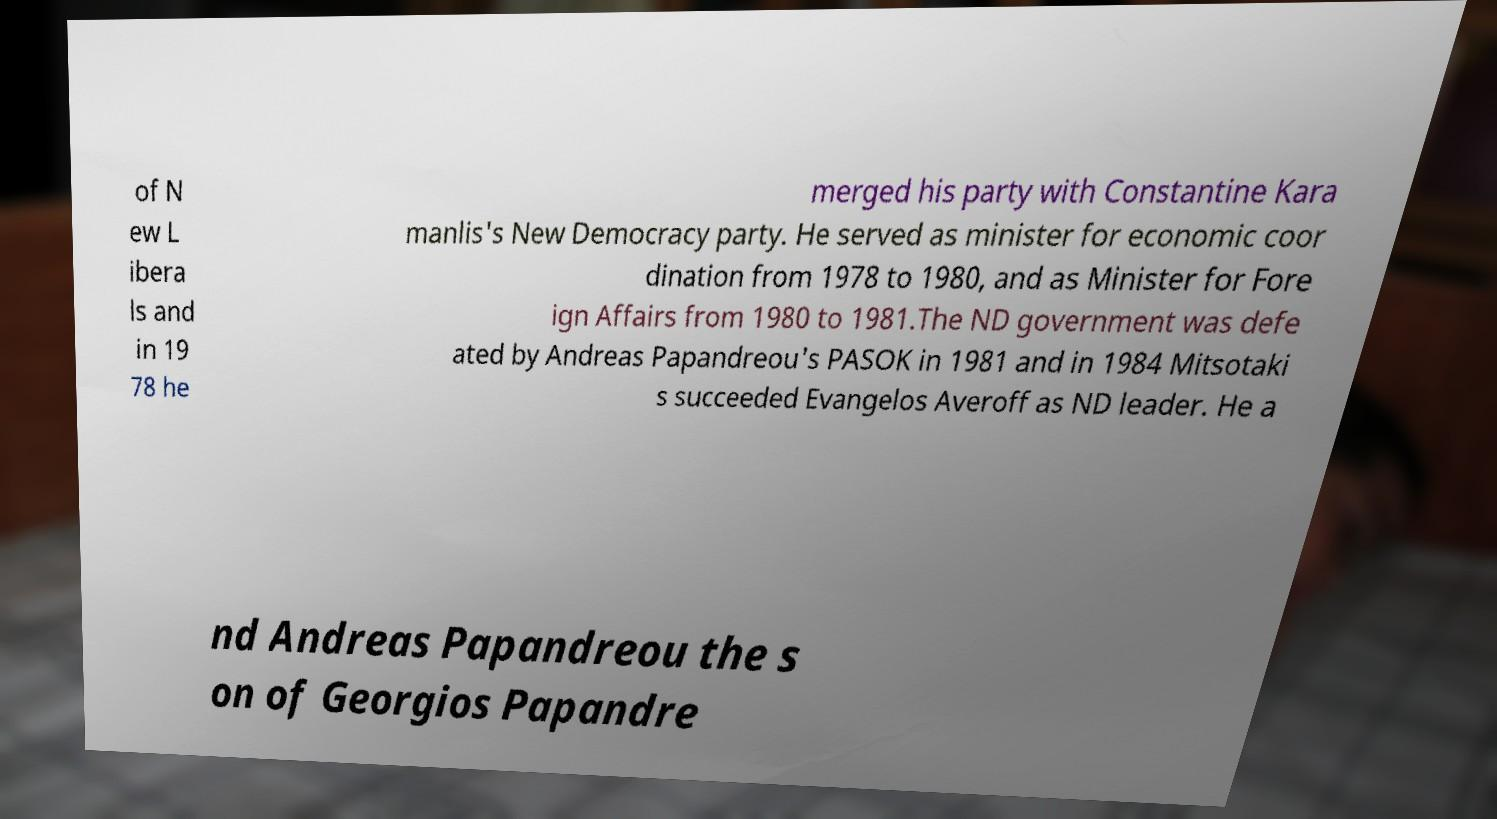Please identify and transcribe the text found in this image. of N ew L ibera ls and in 19 78 he merged his party with Constantine Kara manlis's New Democracy party. He served as minister for economic coor dination from 1978 to 1980, and as Minister for Fore ign Affairs from 1980 to 1981.The ND government was defe ated by Andreas Papandreou's PASOK in 1981 and in 1984 Mitsotaki s succeeded Evangelos Averoff as ND leader. He a nd Andreas Papandreou the s on of Georgios Papandre 